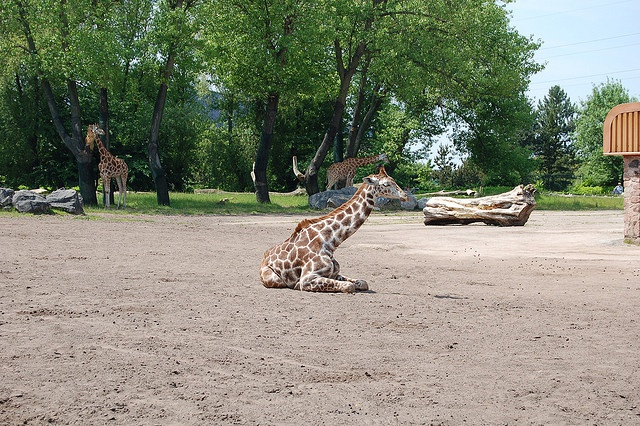Describe the objects in this image and their specific colors. I can see giraffe in darkgreen, lightgray, darkgray, and gray tones, giraffe in darkgreen, gray, black, and maroon tones, giraffe in darkgreen, gray, black, and maroon tones, people in darkgreen, black, gray, lightgray, and darkgray tones, and people in darkgreen, gray, black, purple, and darkgray tones in this image. 